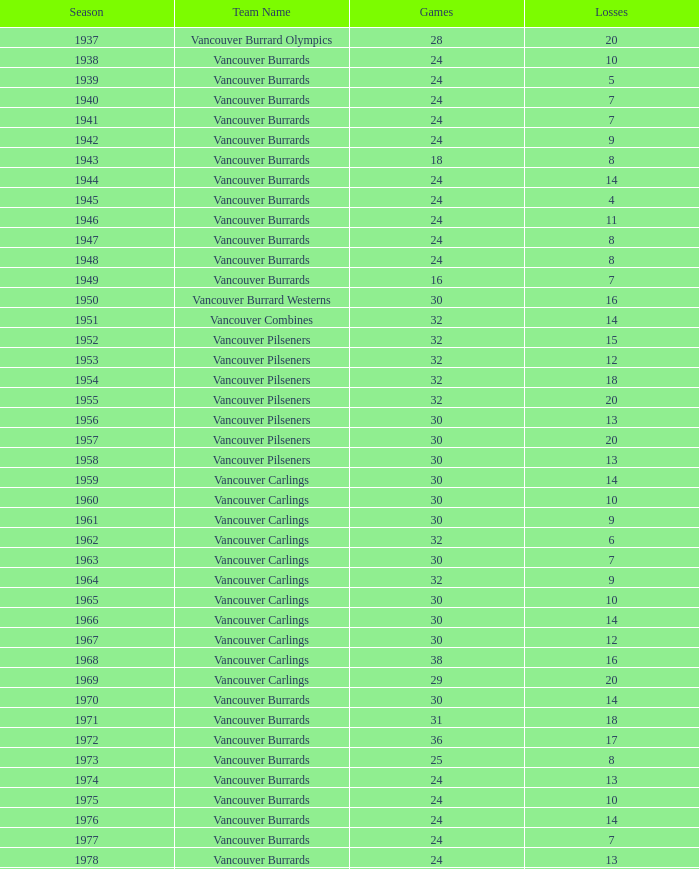When the vancouver carlings have experienced fewer than 12 losses and participated in over 32 games, what is their total point tally? 0.0. 